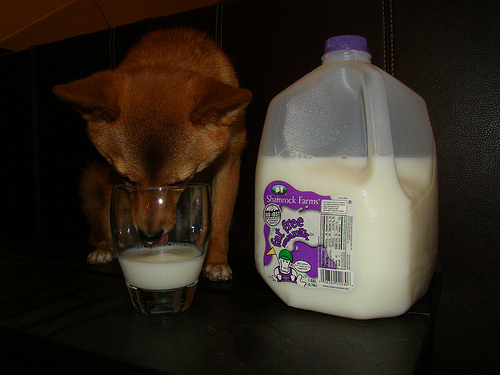<image>
Is there a dog to the left of the milk jug? Yes. From this viewpoint, the dog is positioned to the left side relative to the milk jug. Is there a milk to the right of the glass? Yes. From this viewpoint, the milk is positioned to the right side relative to the glass. Is there a glass next to the jug? Yes. The glass is positioned adjacent to the jug, located nearby in the same general area. 